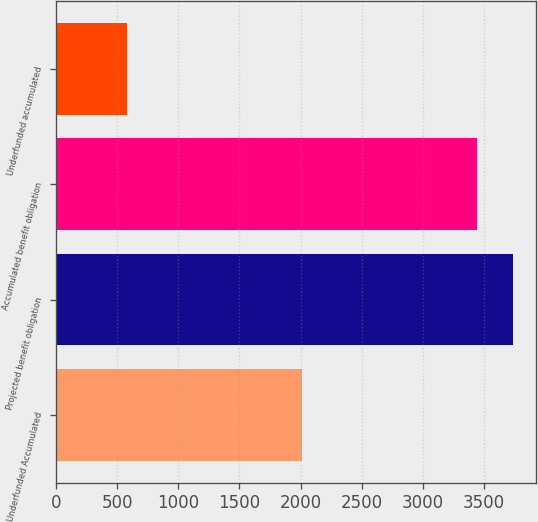Convert chart to OTSL. <chart><loc_0><loc_0><loc_500><loc_500><bar_chart><fcel>Underfunded Accumulated<fcel>Projected benefit obligation<fcel>Accumulated benefit obligation<fcel>Underfunded accumulated<nl><fcel>2012<fcel>3739.1<fcel>3440<fcel>583<nl></chart> 